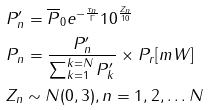Convert formula to latex. <formula><loc_0><loc_0><loc_500><loc_500>& P ^ { \prime } _ { n } = \overline { P } _ { 0 } e ^ { - \frac { \tau _ { n } } { \Gamma } } 1 0 ^ { \frac { Z _ { n } } { 1 0 } } \\ & P _ { n } = \frac { P ^ { \prime } _ { n } } { \sum ^ { k = N } _ { k = 1 } P ^ { \prime } _ { k } } \times P _ { r } [ m W ] \\ & Z _ { n } \sim N ( 0 , 3 ) , n = 1 , 2 , \dots N</formula> 